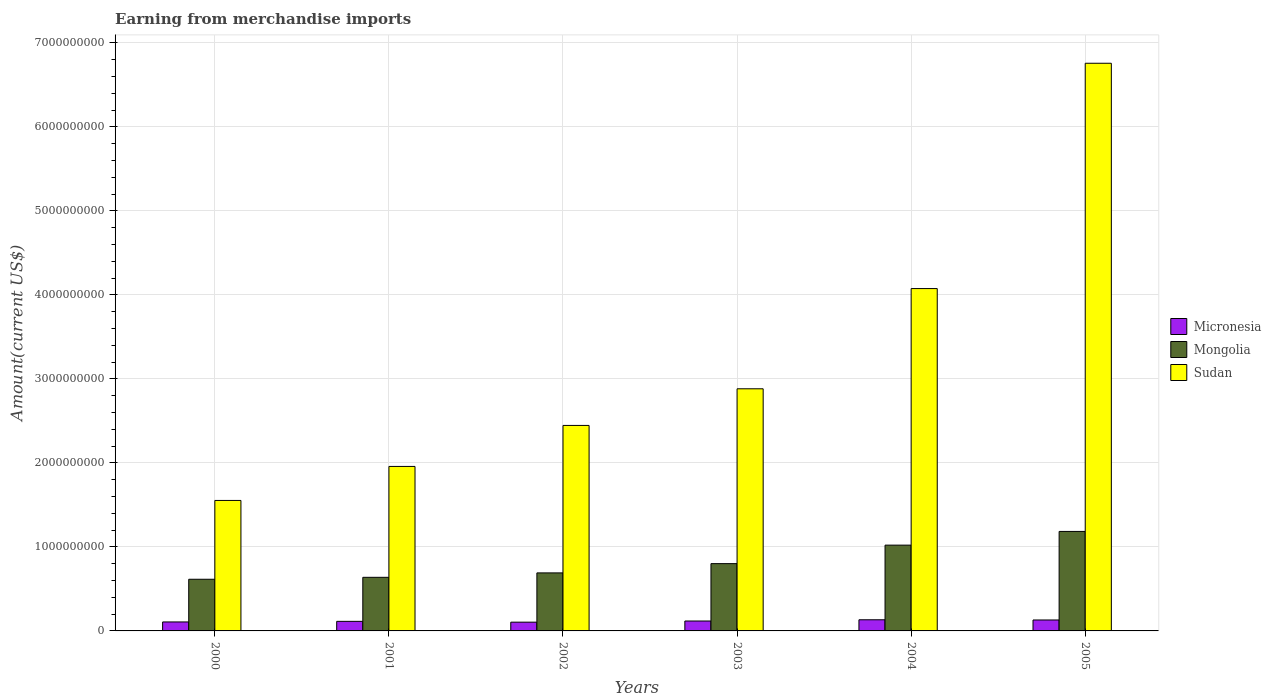How many groups of bars are there?
Your response must be concise. 6. Are the number of bars per tick equal to the number of legend labels?
Your answer should be very brief. Yes. How many bars are there on the 5th tick from the right?
Keep it short and to the point. 3. In how many cases, is the number of bars for a given year not equal to the number of legend labels?
Your answer should be very brief. 0. What is the amount earned from merchandise imports in Mongolia in 2004?
Your answer should be very brief. 1.02e+09. Across all years, what is the maximum amount earned from merchandise imports in Mongolia?
Keep it short and to the point. 1.18e+09. Across all years, what is the minimum amount earned from merchandise imports in Sudan?
Your response must be concise. 1.55e+09. In which year was the amount earned from merchandise imports in Sudan maximum?
Your answer should be compact. 2005. In which year was the amount earned from merchandise imports in Mongolia minimum?
Keep it short and to the point. 2000. What is the total amount earned from merchandise imports in Sudan in the graph?
Your answer should be very brief. 1.97e+1. What is the difference between the amount earned from merchandise imports in Mongolia in 2001 and that in 2004?
Offer a terse response. -3.83e+08. What is the difference between the amount earned from merchandise imports in Sudan in 2005 and the amount earned from merchandise imports in Micronesia in 2002?
Provide a succinct answer. 6.65e+09. What is the average amount earned from merchandise imports in Mongolia per year?
Offer a terse response. 8.25e+08. In the year 2004, what is the difference between the amount earned from merchandise imports in Micronesia and amount earned from merchandise imports in Mongolia?
Provide a short and direct response. -8.88e+08. In how many years, is the amount earned from merchandise imports in Mongolia greater than 1600000000 US$?
Your response must be concise. 0. What is the ratio of the amount earned from merchandise imports in Sudan in 2000 to that in 2004?
Provide a short and direct response. 0.38. Is the amount earned from merchandise imports in Mongolia in 2000 less than that in 2002?
Your answer should be very brief. Yes. Is the difference between the amount earned from merchandise imports in Micronesia in 2002 and 2005 greater than the difference between the amount earned from merchandise imports in Mongolia in 2002 and 2005?
Your answer should be compact. Yes. What is the difference between the highest and the second highest amount earned from merchandise imports in Micronesia?
Your answer should be very brief. 2.48e+06. What is the difference between the highest and the lowest amount earned from merchandise imports in Sudan?
Keep it short and to the point. 5.20e+09. In how many years, is the amount earned from merchandise imports in Sudan greater than the average amount earned from merchandise imports in Sudan taken over all years?
Give a very brief answer. 2. Is the sum of the amount earned from merchandise imports in Mongolia in 2000 and 2004 greater than the maximum amount earned from merchandise imports in Sudan across all years?
Make the answer very short. No. What does the 2nd bar from the left in 2001 represents?
Make the answer very short. Mongolia. What does the 2nd bar from the right in 2003 represents?
Your response must be concise. Mongolia. How many bars are there?
Offer a terse response. 18. How many years are there in the graph?
Offer a very short reply. 6. What is the difference between two consecutive major ticks on the Y-axis?
Make the answer very short. 1.00e+09. How many legend labels are there?
Offer a terse response. 3. How are the legend labels stacked?
Give a very brief answer. Vertical. What is the title of the graph?
Keep it short and to the point. Earning from merchandise imports. Does "Liberia" appear as one of the legend labels in the graph?
Make the answer very short. No. What is the label or title of the X-axis?
Give a very brief answer. Years. What is the label or title of the Y-axis?
Provide a short and direct response. Amount(current US$). What is the Amount(current US$) in Micronesia in 2000?
Offer a terse response. 1.07e+08. What is the Amount(current US$) in Mongolia in 2000?
Offer a very short reply. 6.15e+08. What is the Amount(current US$) in Sudan in 2000?
Offer a very short reply. 1.55e+09. What is the Amount(current US$) of Micronesia in 2001?
Make the answer very short. 1.14e+08. What is the Amount(current US$) of Mongolia in 2001?
Provide a succinct answer. 6.38e+08. What is the Amount(current US$) of Sudan in 2001?
Give a very brief answer. 1.96e+09. What is the Amount(current US$) of Micronesia in 2002?
Provide a short and direct response. 1.04e+08. What is the Amount(current US$) of Mongolia in 2002?
Provide a succinct answer. 6.91e+08. What is the Amount(current US$) in Sudan in 2002?
Offer a terse response. 2.45e+09. What is the Amount(current US$) in Micronesia in 2003?
Offer a very short reply. 1.18e+08. What is the Amount(current US$) of Mongolia in 2003?
Provide a short and direct response. 8.01e+08. What is the Amount(current US$) in Sudan in 2003?
Provide a short and direct response. 2.88e+09. What is the Amount(current US$) of Micronesia in 2004?
Keep it short and to the point. 1.33e+08. What is the Amount(current US$) of Mongolia in 2004?
Provide a succinct answer. 1.02e+09. What is the Amount(current US$) of Sudan in 2004?
Offer a terse response. 4.08e+09. What is the Amount(current US$) in Micronesia in 2005?
Give a very brief answer. 1.30e+08. What is the Amount(current US$) in Mongolia in 2005?
Your answer should be compact. 1.18e+09. What is the Amount(current US$) in Sudan in 2005?
Your response must be concise. 6.76e+09. Across all years, what is the maximum Amount(current US$) of Micronesia?
Your response must be concise. 1.33e+08. Across all years, what is the maximum Amount(current US$) of Mongolia?
Give a very brief answer. 1.18e+09. Across all years, what is the maximum Amount(current US$) in Sudan?
Give a very brief answer. 6.76e+09. Across all years, what is the minimum Amount(current US$) of Micronesia?
Keep it short and to the point. 1.04e+08. Across all years, what is the minimum Amount(current US$) in Mongolia?
Your response must be concise. 6.15e+08. Across all years, what is the minimum Amount(current US$) in Sudan?
Ensure brevity in your answer.  1.55e+09. What is the total Amount(current US$) of Micronesia in the graph?
Your answer should be compact. 7.06e+08. What is the total Amount(current US$) of Mongolia in the graph?
Give a very brief answer. 4.95e+09. What is the total Amount(current US$) of Sudan in the graph?
Provide a succinct answer. 1.97e+1. What is the difference between the Amount(current US$) of Micronesia in 2000 and that in 2001?
Offer a terse response. -7.07e+06. What is the difference between the Amount(current US$) in Mongolia in 2000 and that in 2001?
Your answer should be very brief. -2.30e+07. What is the difference between the Amount(current US$) of Sudan in 2000 and that in 2001?
Ensure brevity in your answer.  -4.05e+08. What is the difference between the Amount(current US$) in Micronesia in 2000 and that in 2002?
Provide a short and direct response. 2.47e+06. What is the difference between the Amount(current US$) of Mongolia in 2000 and that in 2002?
Your answer should be compact. -7.57e+07. What is the difference between the Amount(current US$) in Sudan in 2000 and that in 2002?
Your answer should be compact. -8.93e+08. What is the difference between the Amount(current US$) of Micronesia in 2000 and that in 2003?
Keep it short and to the point. -1.12e+07. What is the difference between the Amount(current US$) in Mongolia in 2000 and that in 2003?
Provide a succinct answer. -1.86e+08. What is the difference between the Amount(current US$) of Sudan in 2000 and that in 2003?
Your response must be concise. -1.33e+09. What is the difference between the Amount(current US$) in Micronesia in 2000 and that in 2004?
Your answer should be compact. -2.59e+07. What is the difference between the Amount(current US$) of Mongolia in 2000 and that in 2004?
Make the answer very short. -4.06e+08. What is the difference between the Amount(current US$) in Sudan in 2000 and that in 2004?
Your answer should be very brief. -2.52e+09. What is the difference between the Amount(current US$) in Micronesia in 2000 and that in 2005?
Provide a succinct answer. -2.35e+07. What is the difference between the Amount(current US$) of Mongolia in 2000 and that in 2005?
Your response must be concise. -5.69e+08. What is the difference between the Amount(current US$) in Sudan in 2000 and that in 2005?
Ensure brevity in your answer.  -5.20e+09. What is the difference between the Amount(current US$) of Micronesia in 2001 and that in 2002?
Your answer should be very brief. 9.54e+06. What is the difference between the Amount(current US$) of Mongolia in 2001 and that in 2002?
Your answer should be compact. -5.27e+07. What is the difference between the Amount(current US$) in Sudan in 2001 and that in 2002?
Offer a very short reply. -4.88e+08. What is the difference between the Amount(current US$) of Micronesia in 2001 and that in 2003?
Keep it short and to the point. -4.09e+06. What is the difference between the Amount(current US$) of Mongolia in 2001 and that in 2003?
Give a very brief answer. -1.63e+08. What is the difference between the Amount(current US$) of Sudan in 2001 and that in 2003?
Offer a terse response. -9.24e+08. What is the difference between the Amount(current US$) in Micronesia in 2001 and that in 2004?
Provide a succinct answer. -1.89e+07. What is the difference between the Amount(current US$) in Mongolia in 2001 and that in 2004?
Provide a short and direct response. -3.83e+08. What is the difference between the Amount(current US$) in Sudan in 2001 and that in 2004?
Ensure brevity in your answer.  -2.12e+09. What is the difference between the Amount(current US$) in Micronesia in 2001 and that in 2005?
Ensure brevity in your answer.  -1.64e+07. What is the difference between the Amount(current US$) of Mongolia in 2001 and that in 2005?
Ensure brevity in your answer.  -5.46e+08. What is the difference between the Amount(current US$) in Sudan in 2001 and that in 2005?
Your answer should be compact. -4.80e+09. What is the difference between the Amount(current US$) in Micronesia in 2002 and that in 2003?
Offer a terse response. -1.36e+07. What is the difference between the Amount(current US$) in Mongolia in 2002 and that in 2003?
Provide a succinct answer. -1.10e+08. What is the difference between the Amount(current US$) in Sudan in 2002 and that in 2003?
Your answer should be compact. -4.36e+08. What is the difference between the Amount(current US$) in Micronesia in 2002 and that in 2004?
Keep it short and to the point. -2.84e+07. What is the difference between the Amount(current US$) in Mongolia in 2002 and that in 2004?
Make the answer very short. -3.30e+08. What is the difference between the Amount(current US$) in Sudan in 2002 and that in 2004?
Your answer should be compact. -1.63e+09. What is the difference between the Amount(current US$) in Micronesia in 2002 and that in 2005?
Offer a terse response. -2.59e+07. What is the difference between the Amount(current US$) in Mongolia in 2002 and that in 2005?
Keep it short and to the point. -4.94e+08. What is the difference between the Amount(current US$) of Sudan in 2002 and that in 2005?
Keep it short and to the point. -4.31e+09. What is the difference between the Amount(current US$) of Micronesia in 2003 and that in 2004?
Give a very brief answer. -1.48e+07. What is the difference between the Amount(current US$) of Mongolia in 2003 and that in 2004?
Offer a very short reply. -2.20e+08. What is the difference between the Amount(current US$) in Sudan in 2003 and that in 2004?
Keep it short and to the point. -1.19e+09. What is the difference between the Amount(current US$) of Micronesia in 2003 and that in 2005?
Offer a very short reply. -1.23e+07. What is the difference between the Amount(current US$) of Mongolia in 2003 and that in 2005?
Offer a terse response. -3.83e+08. What is the difference between the Amount(current US$) of Sudan in 2003 and that in 2005?
Provide a short and direct response. -3.87e+09. What is the difference between the Amount(current US$) in Micronesia in 2004 and that in 2005?
Your answer should be compact. 2.48e+06. What is the difference between the Amount(current US$) of Mongolia in 2004 and that in 2005?
Provide a short and direct response. -1.63e+08. What is the difference between the Amount(current US$) in Sudan in 2004 and that in 2005?
Give a very brief answer. -2.68e+09. What is the difference between the Amount(current US$) in Micronesia in 2000 and the Amount(current US$) in Mongolia in 2001?
Provide a succinct answer. -5.31e+08. What is the difference between the Amount(current US$) in Micronesia in 2000 and the Amount(current US$) in Sudan in 2001?
Your answer should be very brief. -1.85e+09. What is the difference between the Amount(current US$) of Mongolia in 2000 and the Amount(current US$) of Sudan in 2001?
Your answer should be very brief. -1.34e+09. What is the difference between the Amount(current US$) of Micronesia in 2000 and the Amount(current US$) of Mongolia in 2002?
Give a very brief answer. -5.84e+08. What is the difference between the Amount(current US$) in Micronesia in 2000 and the Amount(current US$) in Sudan in 2002?
Ensure brevity in your answer.  -2.34e+09. What is the difference between the Amount(current US$) of Mongolia in 2000 and the Amount(current US$) of Sudan in 2002?
Provide a short and direct response. -1.83e+09. What is the difference between the Amount(current US$) of Micronesia in 2000 and the Amount(current US$) of Mongolia in 2003?
Offer a very short reply. -6.94e+08. What is the difference between the Amount(current US$) in Micronesia in 2000 and the Amount(current US$) in Sudan in 2003?
Ensure brevity in your answer.  -2.78e+09. What is the difference between the Amount(current US$) of Mongolia in 2000 and the Amount(current US$) of Sudan in 2003?
Ensure brevity in your answer.  -2.27e+09. What is the difference between the Amount(current US$) in Micronesia in 2000 and the Amount(current US$) in Mongolia in 2004?
Provide a succinct answer. -9.14e+08. What is the difference between the Amount(current US$) in Micronesia in 2000 and the Amount(current US$) in Sudan in 2004?
Your answer should be compact. -3.97e+09. What is the difference between the Amount(current US$) of Mongolia in 2000 and the Amount(current US$) of Sudan in 2004?
Your answer should be compact. -3.46e+09. What is the difference between the Amount(current US$) of Micronesia in 2000 and the Amount(current US$) of Mongolia in 2005?
Offer a very short reply. -1.08e+09. What is the difference between the Amount(current US$) of Micronesia in 2000 and the Amount(current US$) of Sudan in 2005?
Give a very brief answer. -6.65e+09. What is the difference between the Amount(current US$) in Mongolia in 2000 and the Amount(current US$) in Sudan in 2005?
Keep it short and to the point. -6.14e+09. What is the difference between the Amount(current US$) of Micronesia in 2001 and the Amount(current US$) of Mongolia in 2002?
Provide a succinct answer. -5.77e+08. What is the difference between the Amount(current US$) in Micronesia in 2001 and the Amount(current US$) in Sudan in 2002?
Your answer should be very brief. -2.33e+09. What is the difference between the Amount(current US$) of Mongolia in 2001 and the Amount(current US$) of Sudan in 2002?
Offer a very short reply. -1.81e+09. What is the difference between the Amount(current US$) of Micronesia in 2001 and the Amount(current US$) of Mongolia in 2003?
Your response must be concise. -6.87e+08. What is the difference between the Amount(current US$) of Micronesia in 2001 and the Amount(current US$) of Sudan in 2003?
Provide a succinct answer. -2.77e+09. What is the difference between the Amount(current US$) in Mongolia in 2001 and the Amount(current US$) in Sudan in 2003?
Your answer should be compact. -2.24e+09. What is the difference between the Amount(current US$) in Micronesia in 2001 and the Amount(current US$) in Mongolia in 2004?
Keep it short and to the point. -9.07e+08. What is the difference between the Amount(current US$) of Micronesia in 2001 and the Amount(current US$) of Sudan in 2004?
Offer a very short reply. -3.96e+09. What is the difference between the Amount(current US$) of Mongolia in 2001 and the Amount(current US$) of Sudan in 2004?
Offer a very short reply. -3.44e+09. What is the difference between the Amount(current US$) in Micronesia in 2001 and the Amount(current US$) in Mongolia in 2005?
Offer a terse response. -1.07e+09. What is the difference between the Amount(current US$) in Micronesia in 2001 and the Amount(current US$) in Sudan in 2005?
Your answer should be compact. -6.64e+09. What is the difference between the Amount(current US$) of Mongolia in 2001 and the Amount(current US$) of Sudan in 2005?
Offer a very short reply. -6.12e+09. What is the difference between the Amount(current US$) of Micronesia in 2002 and the Amount(current US$) of Mongolia in 2003?
Provide a succinct answer. -6.97e+08. What is the difference between the Amount(current US$) in Micronesia in 2002 and the Amount(current US$) in Sudan in 2003?
Your answer should be compact. -2.78e+09. What is the difference between the Amount(current US$) in Mongolia in 2002 and the Amount(current US$) in Sudan in 2003?
Provide a short and direct response. -2.19e+09. What is the difference between the Amount(current US$) in Micronesia in 2002 and the Amount(current US$) in Mongolia in 2004?
Your response must be concise. -9.17e+08. What is the difference between the Amount(current US$) of Micronesia in 2002 and the Amount(current US$) of Sudan in 2004?
Offer a very short reply. -3.97e+09. What is the difference between the Amount(current US$) of Mongolia in 2002 and the Amount(current US$) of Sudan in 2004?
Provide a succinct answer. -3.38e+09. What is the difference between the Amount(current US$) of Micronesia in 2002 and the Amount(current US$) of Mongolia in 2005?
Provide a succinct answer. -1.08e+09. What is the difference between the Amount(current US$) of Micronesia in 2002 and the Amount(current US$) of Sudan in 2005?
Provide a succinct answer. -6.65e+09. What is the difference between the Amount(current US$) in Mongolia in 2002 and the Amount(current US$) in Sudan in 2005?
Your answer should be very brief. -6.07e+09. What is the difference between the Amount(current US$) in Micronesia in 2003 and the Amount(current US$) in Mongolia in 2004?
Make the answer very short. -9.03e+08. What is the difference between the Amount(current US$) of Micronesia in 2003 and the Amount(current US$) of Sudan in 2004?
Your answer should be compact. -3.96e+09. What is the difference between the Amount(current US$) of Mongolia in 2003 and the Amount(current US$) of Sudan in 2004?
Offer a very short reply. -3.27e+09. What is the difference between the Amount(current US$) of Micronesia in 2003 and the Amount(current US$) of Mongolia in 2005?
Offer a terse response. -1.07e+09. What is the difference between the Amount(current US$) in Micronesia in 2003 and the Amount(current US$) in Sudan in 2005?
Offer a very short reply. -6.64e+09. What is the difference between the Amount(current US$) in Mongolia in 2003 and the Amount(current US$) in Sudan in 2005?
Give a very brief answer. -5.96e+09. What is the difference between the Amount(current US$) in Micronesia in 2004 and the Amount(current US$) in Mongolia in 2005?
Your response must be concise. -1.05e+09. What is the difference between the Amount(current US$) in Micronesia in 2004 and the Amount(current US$) in Sudan in 2005?
Offer a terse response. -6.62e+09. What is the difference between the Amount(current US$) of Mongolia in 2004 and the Amount(current US$) of Sudan in 2005?
Provide a succinct answer. -5.74e+09. What is the average Amount(current US$) of Micronesia per year?
Provide a succinct answer. 1.18e+08. What is the average Amount(current US$) in Mongolia per year?
Your response must be concise. 8.25e+08. What is the average Amount(current US$) in Sudan per year?
Your response must be concise. 3.28e+09. In the year 2000, what is the difference between the Amount(current US$) of Micronesia and Amount(current US$) of Mongolia?
Keep it short and to the point. -5.08e+08. In the year 2000, what is the difference between the Amount(current US$) in Micronesia and Amount(current US$) in Sudan?
Give a very brief answer. -1.45e+09. In the year 2000, what is the difference between the Amount(current US$) of Mongolia and Amount(current US$) of Sudan?
Offer a terse response. -9.38e+08. In the year 2001, what is the difference between the Amount(current US$) of Micronesia and Amount(current US$) of Mongolia?
Ensure brevity in your answer.  -5.24e+08. In the year 2001, what is the difference between the Amount(current US$) of Micronesia and Amount(current US$) of Sudan?
Provide a short and direct response. -1.84e+09. In the year 2001, what is the difference between the Amount(current US$) in Mongolia and Amount(current US$) in Sudan?
Give a very brief answer. -1.32e+09. In the year 2002, what is the difference between the Amount(current US$) in Micronesia and Amount(current US$) in Mongolia?
Your response must be concise. -5.86e+08. In the year 2002, what is the difference between the Amount(current US$) of Micronesia and Amount(current US$) of Sudan?
Offer a very short reply. -2.34e+09. In the year 2002, what is the difference between the Amount(current US$) of Mongolia and Amount(current US$) of Sudan?
Keep it short and to the point. -1.76e+09. In the year 2003, what is the difference between the Amount(current US$) in Micronesia and Amount(current US$) in Mongolia?
Your response must be concise. -6.83e+08. In the year 2003, what is the difference between the Amount(current US$) in Micronesia and Amount(current US$) in Sudan?
Give a very brief answer. -2.76e+09. In the year 2003, what is the difference between the Amount(current US$) in Mongolia and Amount(current US$) in Sudan?
Your answer should be very brief. -2.08e+09. In the year 2004, what is the difference between the Amount(current US$) in Micronesia and Amount(current US$) in Mongolia?
Your answer should be compact. -8.88e+08. In the year 2004, what is the difference between the Amount(current US$) in Micronesia and Amount(current US$) in Sudan?
Provide a succinct answer. -3.94e+09. In the year 2004, what is the difference between the Amount(current US$) in Mongolia and Amount(current US$) in Sudan?
Offer a very short reply. -3.05e+09. In the year 2005, what is the difference between the Amount(current US$) of Micronesia and Amount(current US$) of Mongolia?
Provide a succinct answer. -1.05e+09. In the year 2005, what is the difference between the Amount(current US$) of Micronesia and Amount(current US$) of Sudan?
Your answer should be compact. -6.63e+09. In the year 2005, what is the difference between the Amount(current US$) of Mongolia and Amount(current US$) of Sudan?
Provide a succinct answer. -5.57e+09. What is the ratio of the Amount(current US$) of Micronesia in 2000 to that in 2001?
Provide a short and direct response. 0.94. What is the ratio of the Amount(current US$) in Mongolia in 2000 to that in 2001?
Provide a short and direct response. 0.96. What is the ratio of the Amount(current US$) of Sudan in 2000 to that in 2001?
Ensure brevity in your answer.  0.79. What is the ratio of the Amount(current US$) in Micronesia in 2000 to that in 2002?
Give a very brief answer. 1.02. What is the ratio of the Amount(current US$) of Mongolia in 2000 to that in 2002?
Provide a short and direct response. 0.89. What is the ratio of the Amount(current US$) of Sudan in 2000 to that in 2002?
Provide a succinct answer. 0.63. What is the ratio of the Amount(current US$) of Micronesia in 2000 to that in 2003?
Ensure brevity in your answer.  0.91. What is the ratio of the Amount(current US$) of Mongolia in 2000 to that in 2003?
Provide a short and direct response. 0.77. What is the ratio of the Amount(current US$) in Sudan in 2000 to that in 2003?
Give a very brief answer. 0.54. What is the ratio of the Amount(current US$) in Micronesia in 2000 to that in 2004?
Provide a succinct answer. 0.8. What is the ratio of the Amount(current US$) of Mongolia in 2000 to that in 2004?
Make the answer very short. 0.6. What is the ratio of the Amount(current US$) of Sudan in 2000 to that in 2004?
Your answer should be compact. 0.38. What is the ratio of the Amount(current US$) of Micronesia in 2000 to that in 2005?
Offer a terse response. 0.82. What is the ratio of the Amount(current US$) of Mongolia in 2000 to that in 2005?
Your response must be concise. 0.52. What is the ratio of the Amount(current US$) of Sudan in 2000 to that in 2005?
Provide a short and direct response. 0.23. What is the ratio of the Amount(current US$) of Micronesia in 2001 to that in 2002?
Your answer should be very brief. 1.09. What is the ratio of the Amount(current US$) in Mongolia in 2001 to that in 2002?
Your response must be concise. 0.92. What is the ratio of the Amount(current US$) of Sudan in 2001 to that in 2002?
Your answer should be compact. 0.8. What is the ratio of the Amount(current US$) of Micronesia in 2001 to that in 2003?
Your answer should be very brief. 0.97. What is the ratio of the Amount(current US$) of Mongolia in 2001 to that in 2003?
Your answer should be very brief. 0.8. What is the ratio of the Amount(current US$) in Sudan in 2001 to that in 2003?
Your response must be concise. 0.68. What is the ratio of the Amount(current US$) of Micronesia in 2001 to that in 2004?
Your answer should be compact. 0.86. What is the ratio of the Amount(current US$) of Mongolia in 2001 to that in 2004?
Offer a terse response. 0.62. What is the ratio of the Amount(current US$) in Sudan in 2001 to that in 2004?
Your answer should be very brief. 0.48. What is the ratio of the Amount(current US$) of Micronesia in 2001 to that in 2005?
Offer a very short reply. 0.87. What is the ratio of the Amount(current US$) of Mongolia in 2001 to that in 2005?
Provide a succinct answer. 0.54. What is the ratio of the Amount(current US$) in Sudan in 2001 to that in 2005?
Give a very brief answer. 0.29. What is the ratio of the Amount(current US$) of Micronesia in 2002 to that in 2003?
Provide a short and direct response. 0.88. What is the ratio of the Amount(current US$) of Mongolia in 2002 to that in 2003?
Give a very brief answer. 0.86. What is the ratio of the Amount(current US$) of Sudan in 2002 to that in 2003?
Your answer should be compact. 0.85. What is the ratio of the Amount(current US$) in Micronesia in 2002 to that in 2004?
Your answer should be compact. 0.79. What is the ratio of the Amount(current US$) of Mongolia in 2002 to that in 2004?
Provide a succinct answer. 0.68. What is the ratio of the Amount(current US$) of Sudan in 2002 to that in 2004?
Provide a short and direct response. 0.6. What is the ratio of the Amount(current US$) of Micronesia in 2002 to that in 2005?
Provide a short and direct response. 0.8. What is the ratio of the Amount(current US$) in Mongolia in 2002 to that in 2005?
Make the answer very short. 0.58. What is the ratio of the Amount(current US$) of Sudan in 2002 to that in 2005?
Your response must be concise. 0.36. What is the ratio of the Amount(current US$) in Micronesia in 2003 to that in 2004?
Your answer should be compact. 0.89. What is the ratio of the Amount(current US$) of Mongolia in 2003 to that in 2004?
Your answer should be compact. 0.78. What is the ratio of the Amount(current US$) in Sudan in 2003 to that in 2004?
Make the answer very short. 0.71. What is the ratio of the Amount(current US$) of Micronesia in 2003 to that in 2005?
Your answer should be compact. 0.91. What is the ratio of the Amount(current US$) in Mongolia in 2003 to that in 2005?
Provide a short and direct response. 0.68. What is the ratio of the Amount(current US$) of Sudan in 2003 to that in 2005?
Offer a very short reply. 0.43. What is the ratio of the Amount(current US$) in Micronesia in 2004 to that in 2005?
Provide a succinct answer. 1.02. What is the ratio of the Amount(current US$) of Mongolia in 2004 to that in 2005?
Ensure brevity in your answer.  0.86. What is the ratio of the Amount(current US$) in Sudan in 2004 to that in 2005?
Your answer should be very brief. 0.6. What is the difference between the highest and the second highest Amount(current US$) of Micronesia?
Give a very brief answer. 2.48e+06. What is the difference between the highest and the second highest Amount(current US$) of Mongolia?
Offer a terse response. 1.63e+08. What is the difference between the highest and the second highest Amount(current US$) of Sudan?
Offer a very short reply. 2.68e+09. What is the difference between the highest and the lowest Amount(current US$) in Micronesia?
Keep it short and to the point. 2.84e+07. What is the difference between the highest and the lowest Amount(current US$) of Mongolia?
Provide a short and direct response. 5.69e+08. What is the difference between the highest and the lowest Amount(current US$) of Sudan?
Give a very brief answer. 5.20e+09. 